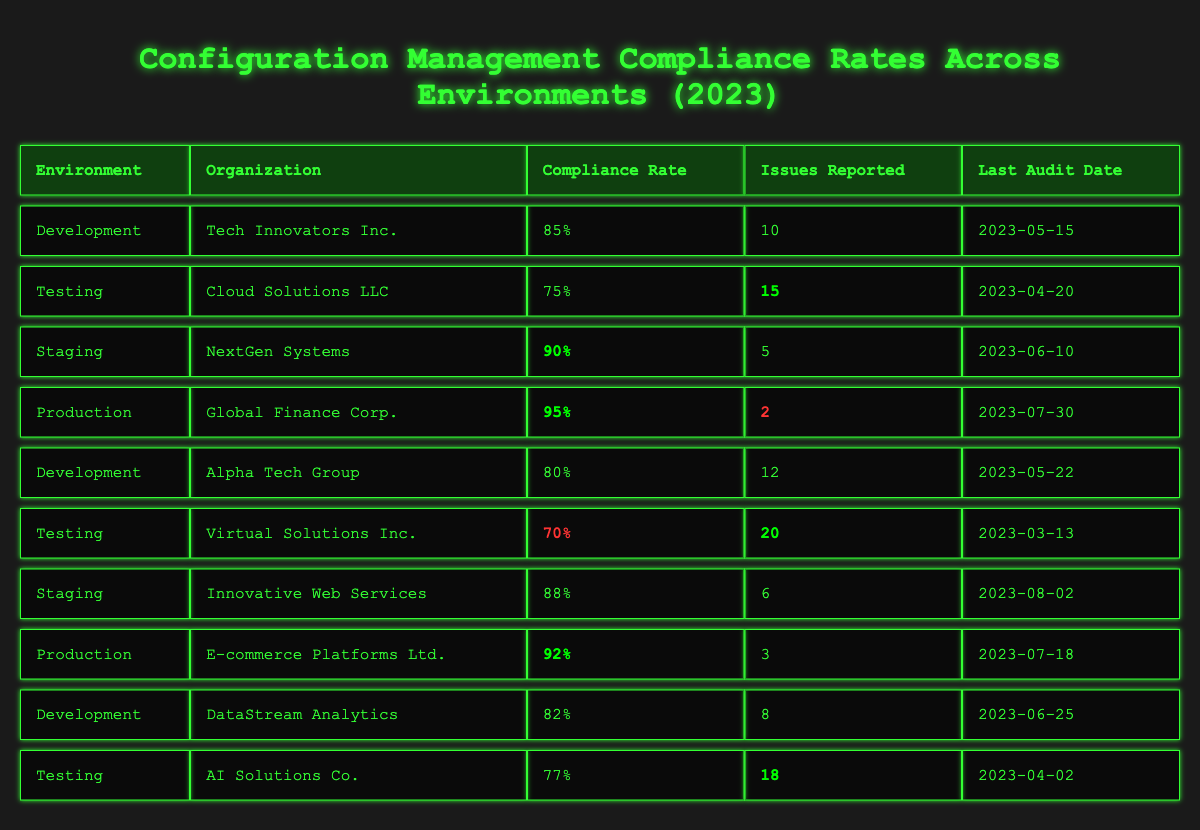What is the compliance rate for the Production environment for Global Finance Corp.? In the table, in the row corresponding to the Production environment and Global Finance Corp., the compliance rate listed is 95%.
Answer: 95% Which organization had the lowest compliance rate in the Testing environment? In the Testing rows, Virtual Solutions Inc. has a compliance rate of 70%, which is the lowest when compared to Cloud Solutions LLC (75%) and AI Solutions Co. (77%).
Answer: Virtual Solutions Inc How many issues were reported in total across all environments? By adding the number of issues reported: 10 + 15 + 5 + 2 + 12 + 20 + 6 + 3 + 8 + 18 = 99.
Answer: 99 What is the average compliance rate across all environments? The compliance rates are 85%, 75%, 90%, 95%, 80%, 70%, 88%, 92%, 82%, 77%. Summing them gives 85 + 75 + 90 + 95 + 80 + 70 + 88 + 92 + 82 + 77 =  919, then dividing by 10 gives 919 / 10 = 91.9%.
Answer: 91.9% Did any organization report issues below 5 in production? Checking the table, Global Finance Corp. reported 2 issues, which is below 5.
Answer: Yes Which environment has the highest compliance rate and what is that rate? The Production environment for Global Finance Corp. has the highest compliance rate at 95%.
Answer: 95% How many more issues did Virtual Solutions Inc. report compared to AI Solutions Co. in the Testing environment? Virtual Solutions Inc. reported 20 issues while AI Solutions Co. reported 18. The difference is 20 - 18 = 2.
Answer: 2 Which staging organization had a compliance rate above average? The average compliance rate calculated earlier is 91.9%. Among the Staging organizations, NextGen Systems has 90% and Innovative Web Services has 88%. Both are below the average, so the answer is none.
Answer: None Is the compliance rate for Development by Tech Innovators Inc. higher than that of Alpha Tech Group? Tech Innovators Inc. has a compliance rate of 85% while Alpha Tech Group has 80%. Since 85% > 80%, the statement is true.
Answer: Yes How do compliance rates in the Development environment compare to those in the Testing environment? The compliance rates in Development are 85% (Tech Innovators Inc.) and 80% (Alpha Tech Group) compared to the Testing rates of 75% (Cloud Solutions LLC), 70% (Virtual Solutions Inc.), and 77% (AI Solutions Co.). The highest in Development is higher than the highest in Testing, while the lowest in Development is also higher than the lowest in Testing.
Answer: Higher 